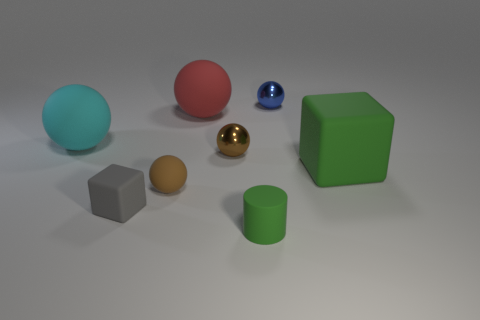Subtract all big cyan balls. How many balls are left? 4 Subtract all purple cylinders. How many brown spheres are left? 2 Add 2 big green rubber objects. How many objects exist? 10 Subtract all brown cylinders. Subtract all red balls. How many cylinders are left? 1 Subtract all small cyan balls. Subtract all large green rubber cubes. How many objects are left? 7 Add 4 big matte spheres. How many big matte spheres are left? 6 Add 2 tiny gray rubber objects. How many tiny gray rubber objects exist? 3 Subtract all green cubes. How many cubes are left? 1 Subtract 1 green blocks. How many objects are left? 7 Subtract all spheres. How many objects are left? 3 